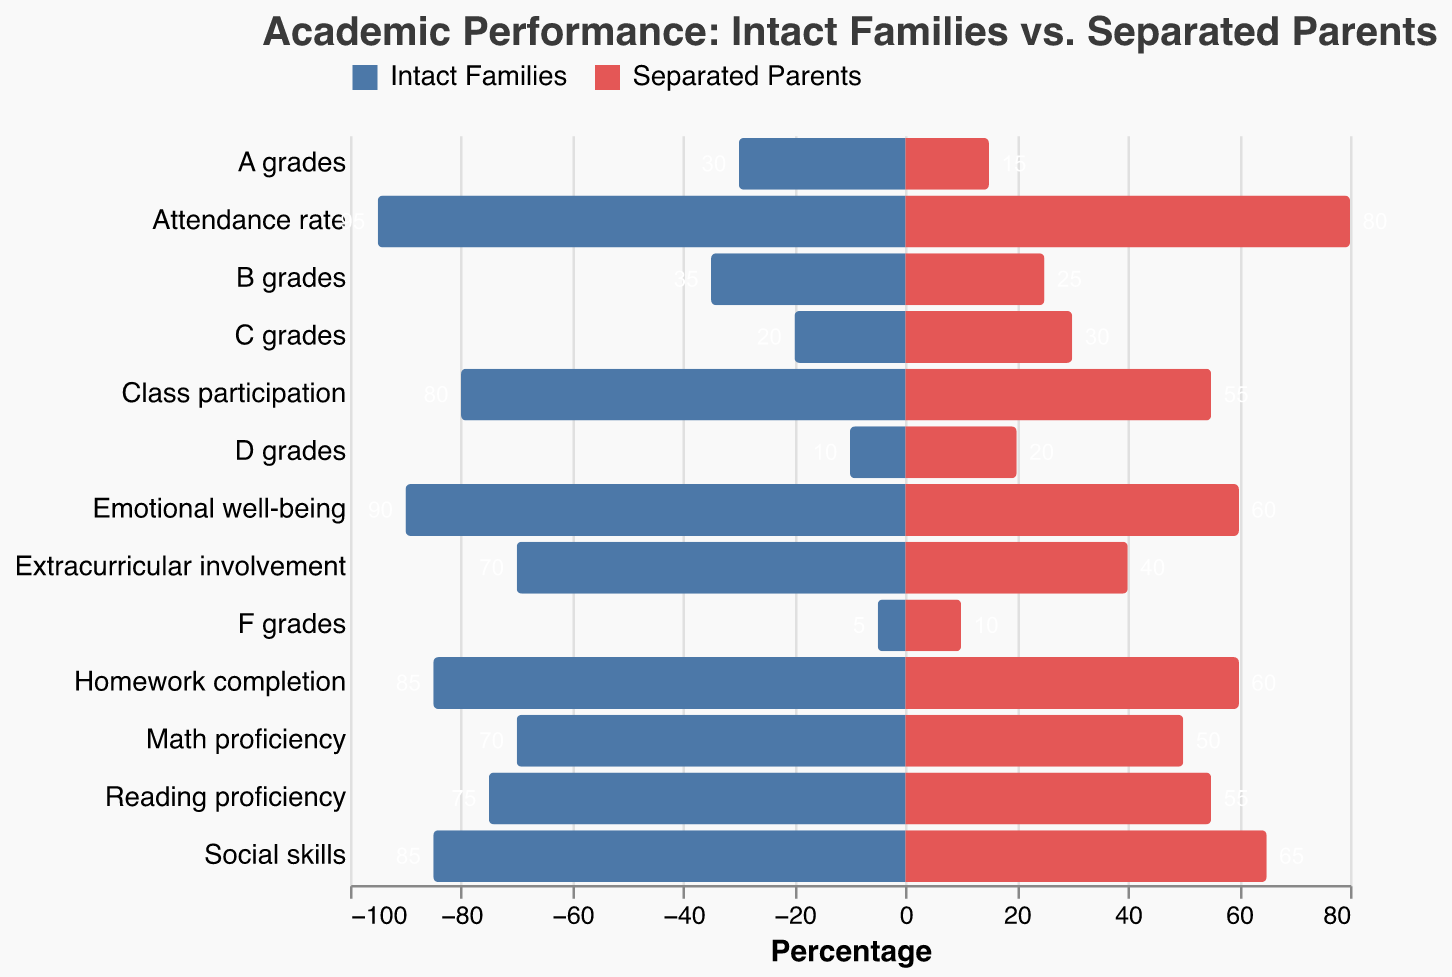What is the title of the figure? The title of the figure is shown at the top and provides information about the contents of the chart.
Answer: Academic Performance: Intact Families vs. Separated Parents What is the percentage of children with 'A grades' from intact families? Locate the 'A grades' category on the y-axis and look at the bar for 'Intact Families'. Read the percentage value.
Answer: 30% What category shows the largest difference in percentage between intact families and separated parents? Compare the difference in percentage for each category by calculating the absolute difference between the values for intact families and separated parents.
Answer: Homework completion Which family type has higher class participation rates? Look at the 'Class participation' category and compare the values for intact families and separated parents.
Answer: Intact Families What is the attendance rate for children from separated parents? Locate the 'Attendance rate' category on the y-axis, and read the value for 'Separated Parents'.
Answer: 80% How much higher is the reading proficiency rate in intact families compared to separated parents? Subtract the reading proficiency percentage of separated parents from that of intact families.
Answer: 75% - 55% = 20% Which category has the lowest percentage for children from separated parents? Look through all the percentages for separated parents to find the smallest value.
Answer: F grades What is the total percentage of students receiving 'C grades' from both family types combined? Sum the 'C grades' percentages for intact families and separated parents.
Answer: 20% + 30% = 50% In which category do both family types have equal values, and what is that value? Check all categories to see where both intact families and separated parents have the same percentage value.
Answer: None 